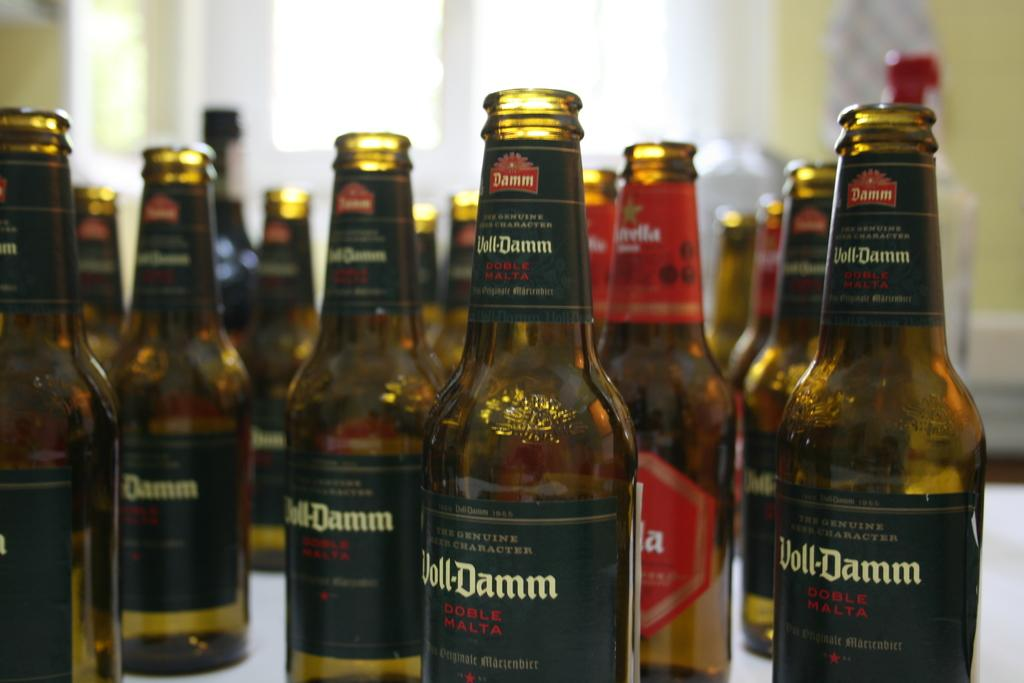<image>
Present a compact description of the photo's key features. A bunch of bottles on a table labeled Voll-Damn. 